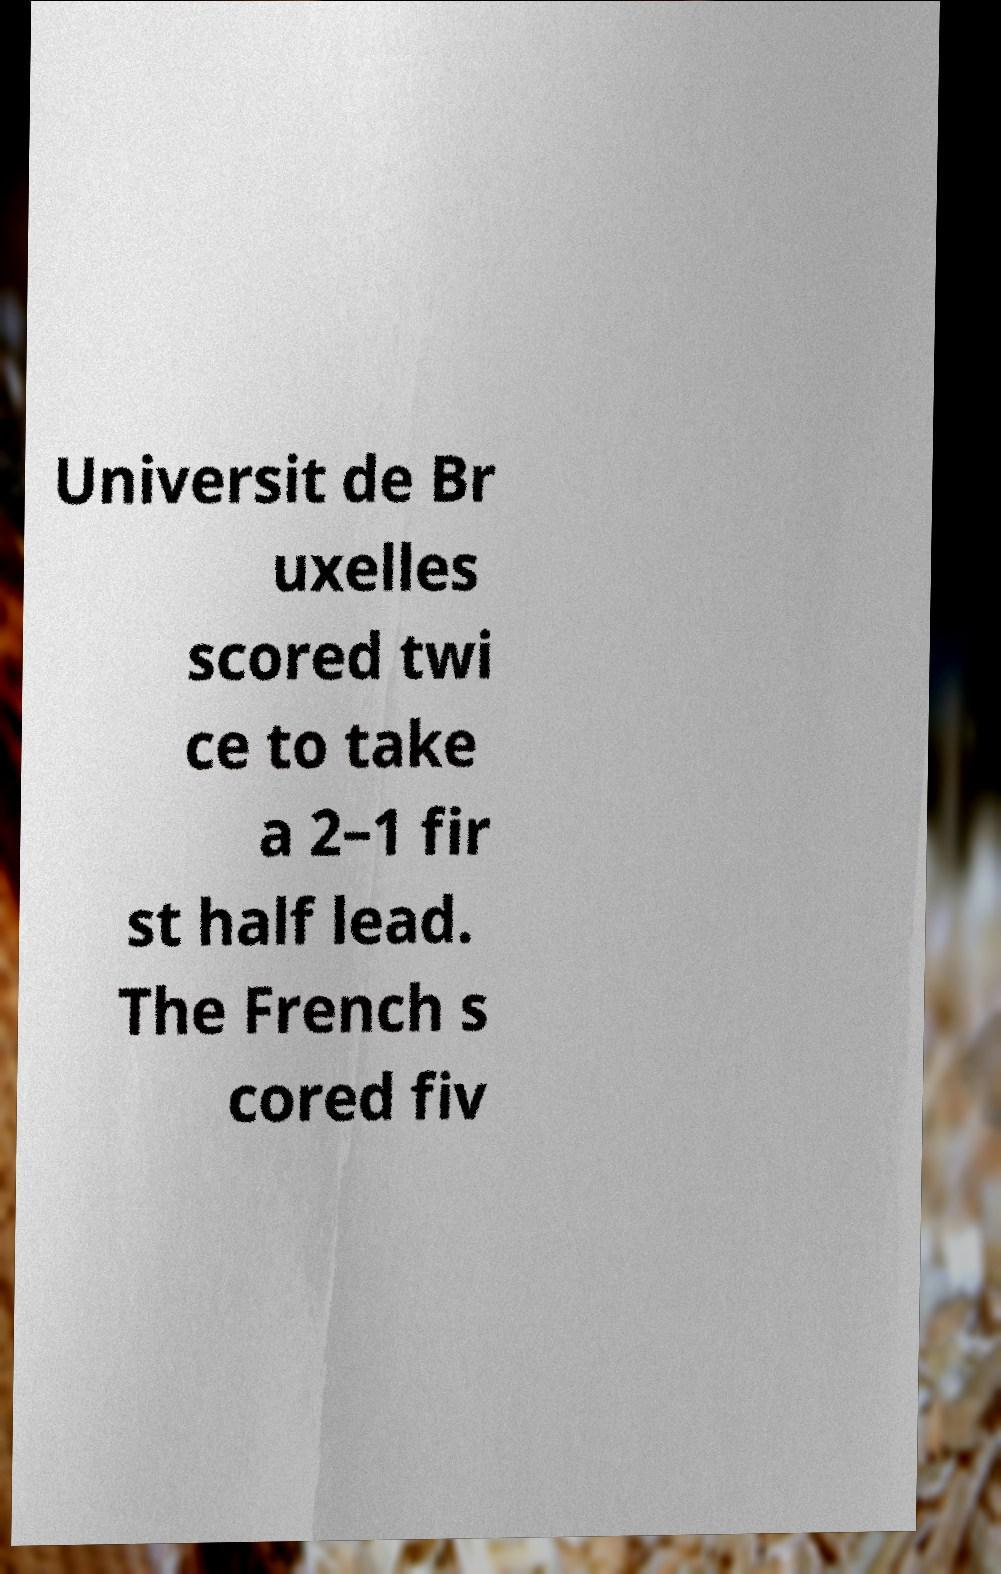There's text embedded in this image that I need extracted. Can you transcribe it verbatim? Universit de Br uxelles scored twi ce to take a 2–1 fir st half lead. The French s cored fiv 